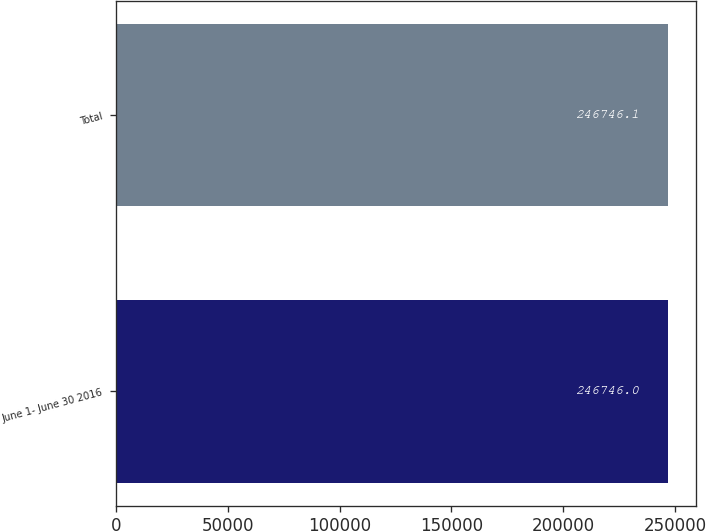<chart> <loc_0><loc_0><loc_500><loc_500><bar_chart><fcel>June 1- June 30 2016<fcel>Total<nl><fcel>246746<fcel>246746<nl></chart> 